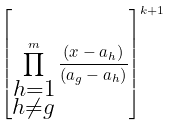Convert formula to latex. <formula><loc_0><loc_0><loc_500><loc_500>\left [ \prod ^ { m } _ { \substack { h = 1 \\ h \neq g } } \frac { ( x - a _ { h } ) } { ( a _ { g } - a _ { h } ) } \right ] ^ { k + 1 }</formula> 